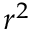<formula> <loc_0><loc_0><loc_500><loc_500>r ^ { 2 }</formula> 